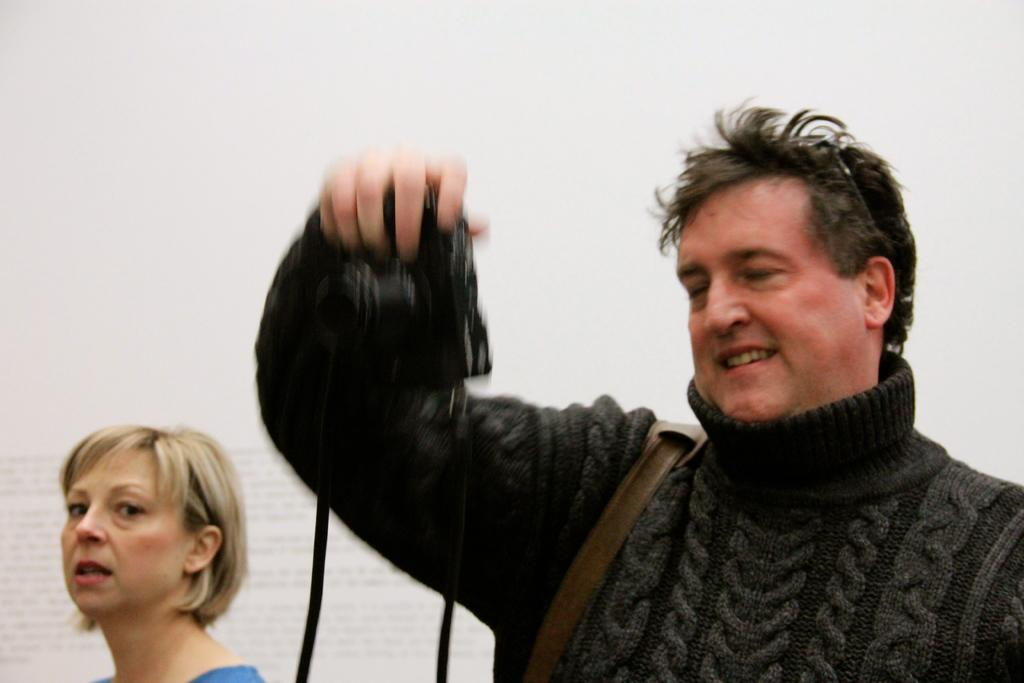How many people are in the image? There are two persons standing in the image. Can you describe the appearance of the man in the image? The man is wearing a sweater. What is the gender of the other person in the image? The other person is a woman. What is the color of the background in the image? The background of the image is white. What type of harmony is being played by the wall in the image? There is no wall or harmony present in the image. Can you tell me how many parents are visible in the image? There is no parent visible in the image; it features two persons, a man and a woman. 